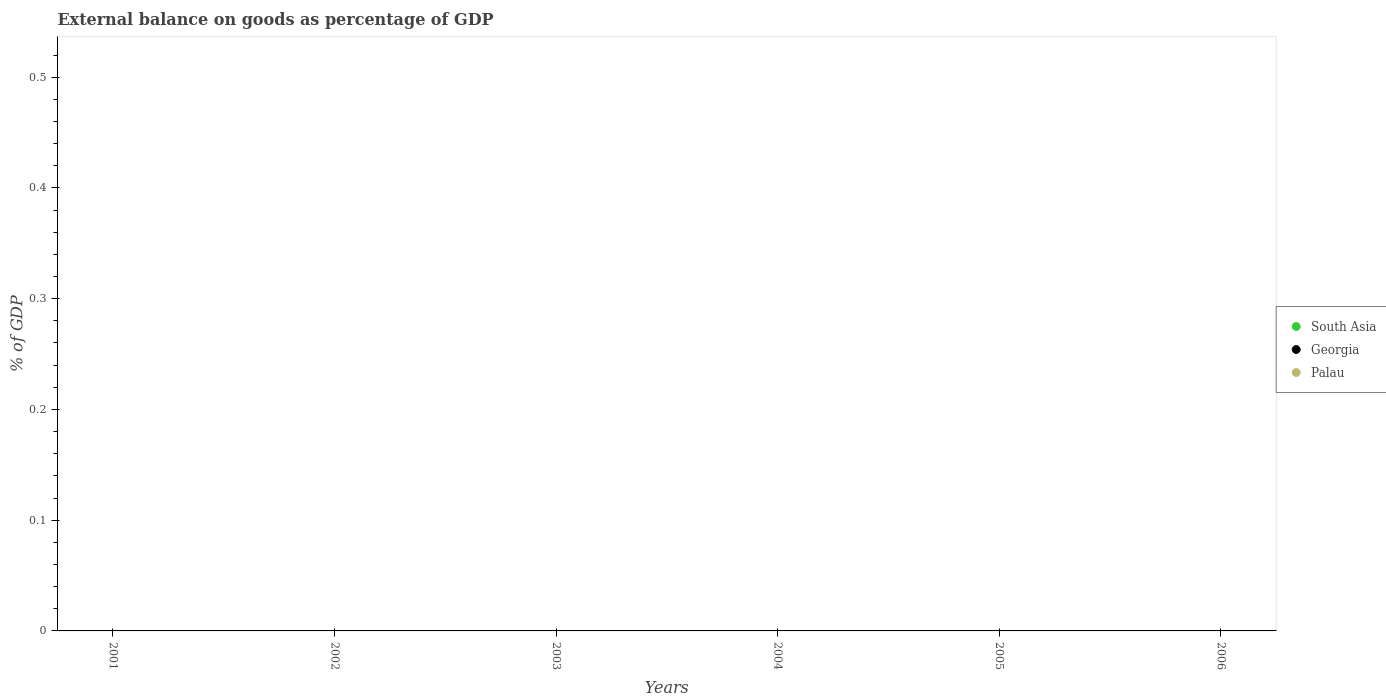What is the external balance on goods as percentage of GDP in South Asia in 2002?
Your response must be concise. 0. Across all years, what is the minimum external balance on goods as percentage of GDP in Georgia?
Offer a very short reply. 0. What is the average external balance on goods as percentage of GDP in Palau per year?
Provide a succinct answer. 0. Is it the case that in every year, the sum of the external balance on goods as percentage of GDP in Georgia and external balance on goods as percentage of GDP in South Asia  is greater than the external balance on goods as percentage of GDP in Palau?
Keep it short and to the point. No. Is the external balance on goods as percentage of GDP in Palau strictly greater than the external balance on goods as percentage of GDP in Georgia over the years?
Keep it short and to the point. No. Does the graph contain grids?
Keep it short and to the point. No. How many legend labels are there?
Make the answer very short. 3. How are the legend labels stacked?
Provide a succinct answer. Vertical. What is the title of the graph?
Your answer should be very brief. External balance on goods as percentage of GDP. What is the label or title of the X-axis?
Provide a succinct answer. Years. What is the label or title of the Y-axis?
Your answer should be compact. % of GDP. What is the % of GDP in South Asia in 2001?
Your answer should be compact. 0. What is the % of GDP in Georgia in 2001?
Keep it short and to the point. 0. What is the % of GDP of Palau in 2001?
Your answer should be compact. 0. What is the % of GDP of Georgia in 2002?
Your answer should be compact. 0. What is the % of GDP of Palau in 2002?
Give a very brief answer. 0. What is the % of GDP of South Asia in 2004?
Offer a very short reply. 0. What is the % of GDP of Georgia in 2004?
Your response must be concise. 0. What is the % of GDP of Palau in 2004?
Your answer should be very brief. 0. What is the % of GDP of South Asia in 2005?
Offer a terse response. 0. What is the % of GDP in Palau in 2005?
Your answer should be very brief. 0. What is the % of GDP of Palau in 2006?
Ensure brevity in your answer.  0. What is the total % of GDP in South Asia in the graph?
Make the answer very short. 0. What is the total % of GDP in Palau in the graph?
Give a very brief answer. 0. What is the average % of GDP in South Asia per year?
Your response must be concise. 0. What is the average % of GDP in Georgia per year?
Offer a very short reply. 0. 